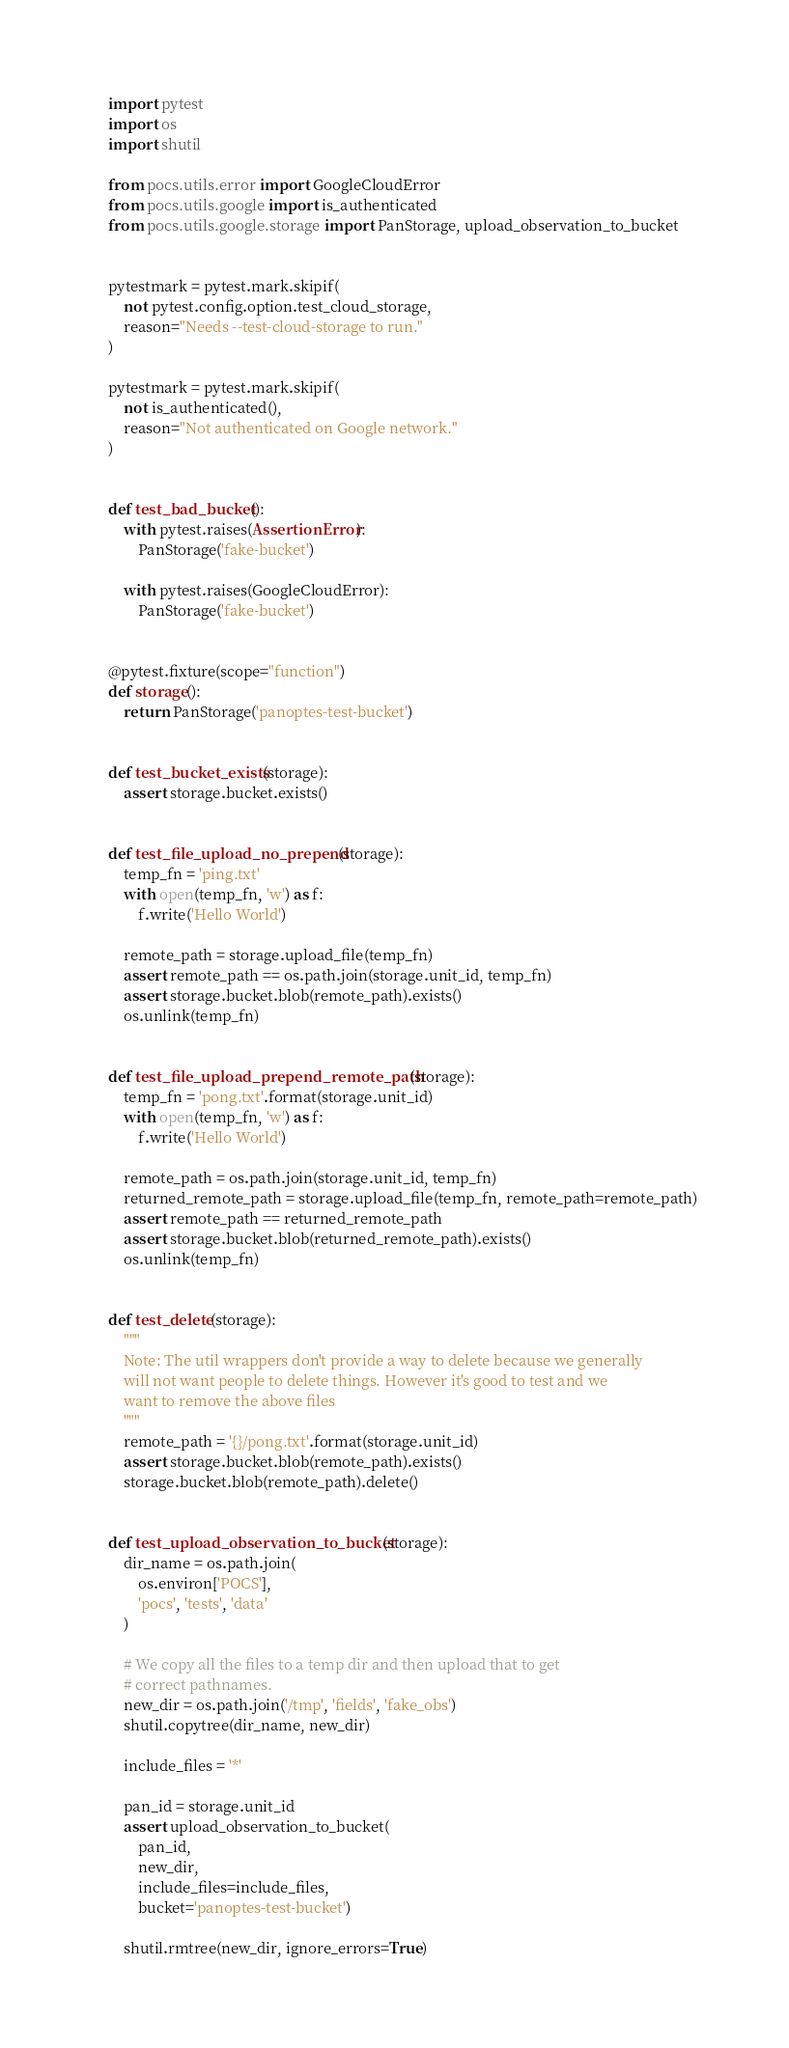Convert code to text. <code><loc_0><loc_0><loc_500><loc_500><_Python_>import pytest
import os
import shutil

from pocs.utils.error import GoogleCloudError
from pocs.utils.google import is_authenticated
from pocs.utils.google.storage import PanStorage, upload_observation_to_bucket


pytestmark = pytest.mark.skipif(
    not pytest.config.option.test_cloud_storage,
    reason="Needs --test-cloud-storage to run."
)

pytestmark = pytest.mark.skipif(
    not is_authenticated(),
    reason="Not authenticated on Google network."
)


def test_bad_bucket():
    with pytest.raises(AssertionError):
        PanStorage('fake-bucket')

    with pytest.raises(GoogleCloudError):
        PanStorage('fake-bucket')


@pytest.fixture(scope="function")
def storage():
    return PanStorage('panoptes-test-bucket')


def test_bucket_exists(storage):
    assert storage.bucket.exists()


def test_file_upload_no_prepend(storage):
    temp_fn = 'ping.txt'
    with open(temp_fn, 'w') as f:
        f.write('Hello World')

    remote_path = storage.upload_file(temp_fn)
    assert remote_path == os.path.join(storage.unit_id, temp_fn)
    assert storage.bucket.blob(remote_path).exists()
    os.unlink(temp_fn)


def test_file_upload_prepend_remote_path(storage):
    temp_fn = 'pong.txt'.format(storage.unit_id)
    with open(temp_fn, 'w') as f:
        f.write('Hello World')

    remote_path = os.path.join(storage.unit_id, temp_fn)
    returned_remote_path = storage.upload_file(temp_fn, remote_path=remote_path)
    assert remote_path == returned_remote_path
    assert storage.bucket.blob(returned_remote_path).exists()
    os.unlink(temp_fn)


def test_delete(storage):
    """
    Note: The util wrappers don't provide a way to delete because we generally
    will not want people to delete things. However it's good to test and we
    want to remove the above files
    """
    remote_path = '{}/pong.txt'.format(storage.unit_id)
    assert storage.bucket.blob(remote_path).exists()
    storage.bucket.blob(remote_path).delete()


def test_upload_observation_to_bucket(storage):
    dir_name = os.path.join(
        os.environ['POCS'],
        'pocs', 'tests', 'data'
    )

    # We copy all the files to a temp dir and then upload that to get
    # correct pathnames.
    new_dir = os.path.join('/tmp', 'fields', 'fake_obs')
    shutil.copytree(dir_name, new_dir)

    include_files = '*'

    pan_id = storage.unit_id
    assert upload_observation_to_bucket(
        pan_id,
        new_dir,
        include_files=include_files,
        bucket='panoptes-test-bucket')

    shutil.rmtree(new_dir, ignore_errors=True)
</code> 